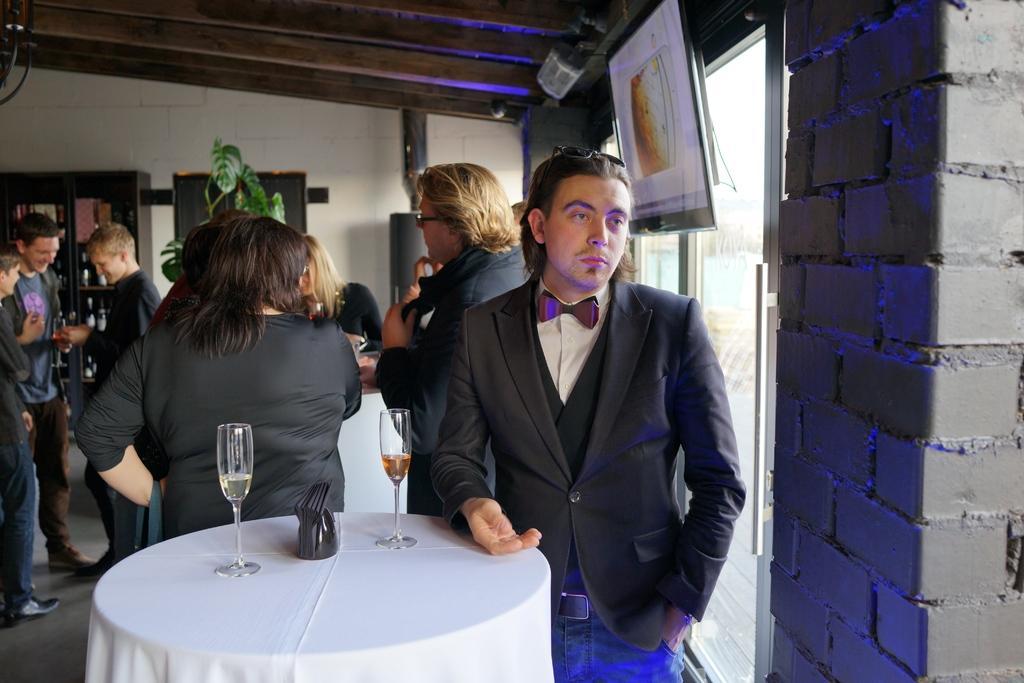How would you summarize this image in a sentence or two? In this image, group of people are stand, few are holding glasses. In this image, there are few table, few items are placed on it. Right side, we can see brick wall , glass windows, banner. And the background, we can see plants, some cupboard, few items are filled in it and wall. 